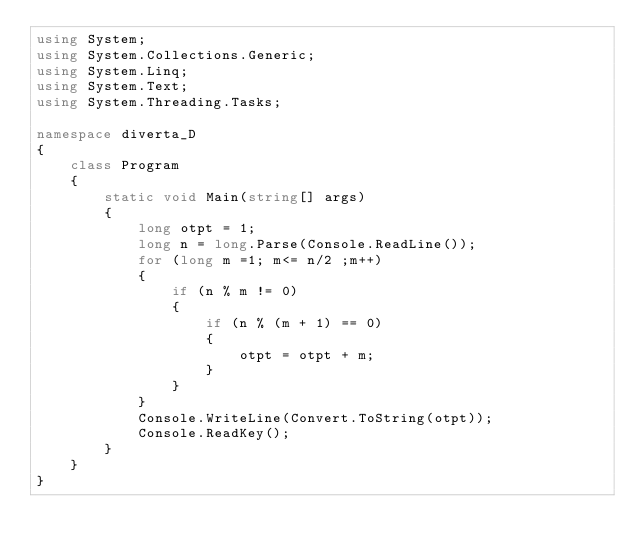<code> <loc_0><loc_0><loc_500><loc_500><_C#_>using System;
using System.Collections.Generic;
using System.Linq;
using System.Text;
using System.Threading.Tasks;

namespace diverta_D
{
    class Program
    {
        static void Main(string[] args)
        {
            long otpt = 1;
            long n = long.Parse(Console.ReadLine());
            for (long m =1; m<= n/2 ;m++)
            {
                if (n % m != 0)
                {
                    if (n % (m + 1) == 0)
                    {
                        otpt = otpt + m;
                    }
                }
            }
            Console.WriteLine(Convert.ToString(otpt));
            Console.ReadKey();
        }
    }
}
</code> 